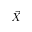Convert formula to latex. <formula><loc_0><loc_0><loc_500><loc_500>\vec { X }</formula> 